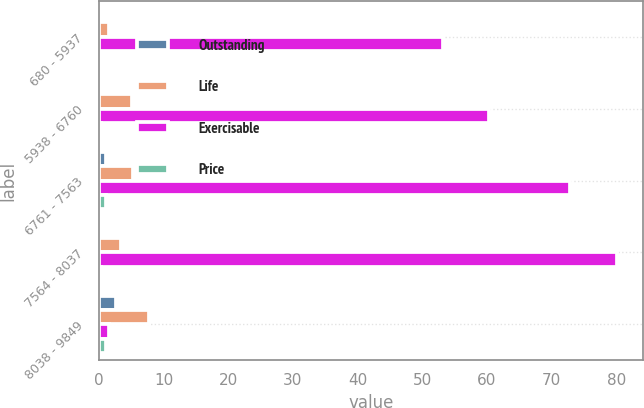<chart> <loc_0><loc_0><loc_500><loc_500><stacked_bar_chart><ecel><fcel>680 - 5937<fcel>5938 - 6760<fcel>6761 - 7563<fcel>7564 - 8037<fcel>8038 - 9849<nl><fcel>Outstanding<fcel>0.1<fcel>0.4<fcel>1.1<fcel>0.4<fcel>2.6<nl><fcel>Life<fcel>1.6<fcel>5.1<fcel>5.3<fcel>3.4<fcel>7.8<nl><fcel>Exercisable<fcel>53.25<fcel>60.32<fcel>72.82<fcel>80.07<fcel>1.6<nl><fcel>Price<fcel>0.1<fcel>0.4<fcel>1.1<fcel>0.4<fcel>1.1<nl></chart> 